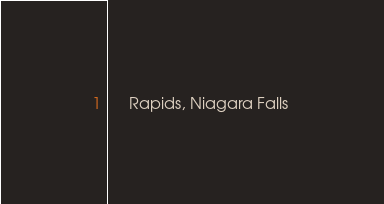Convert code to text. <code><loc_0><loc_0><loc_500><loc_500><_XML_>	 Rapids, Niagara Falls 
</code> 